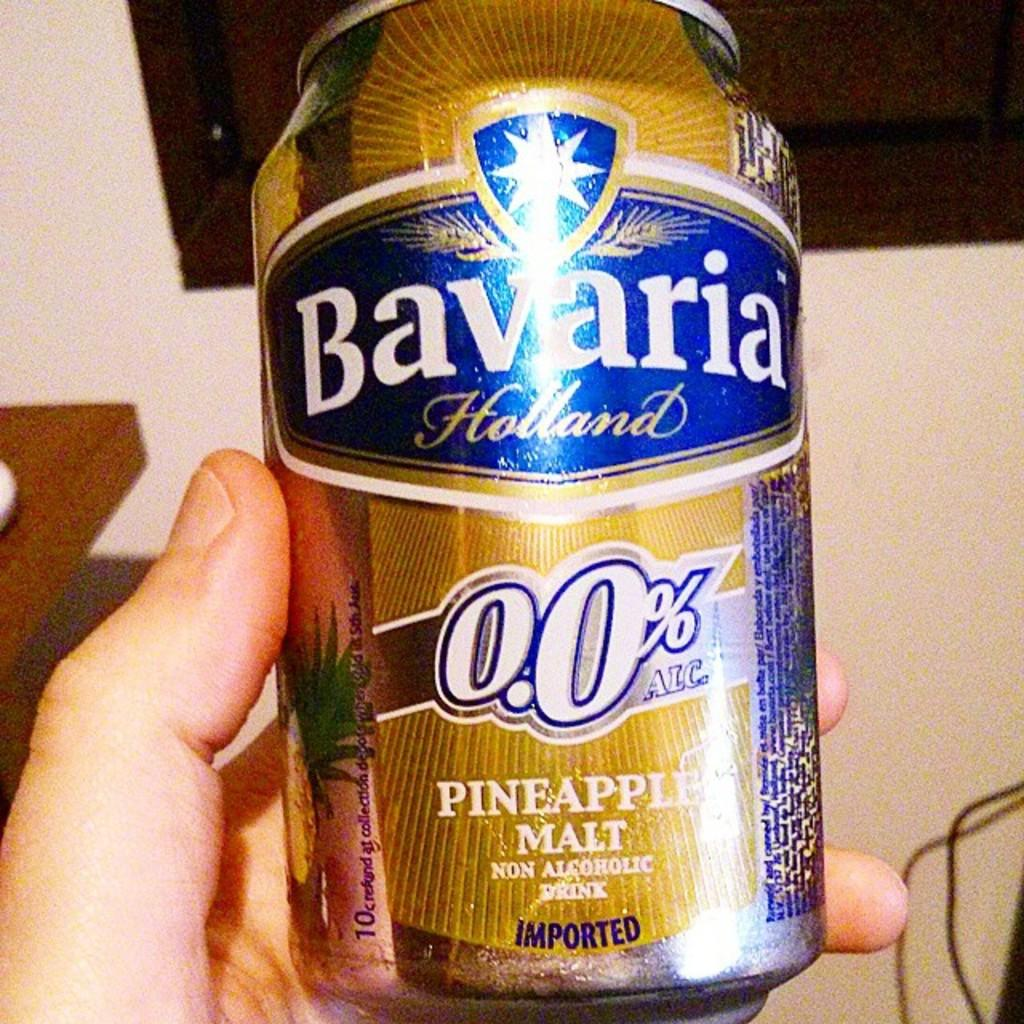Provide a one-sentence caption for the provided image. Someone is holding a can of Bavaria pineapple malt. 